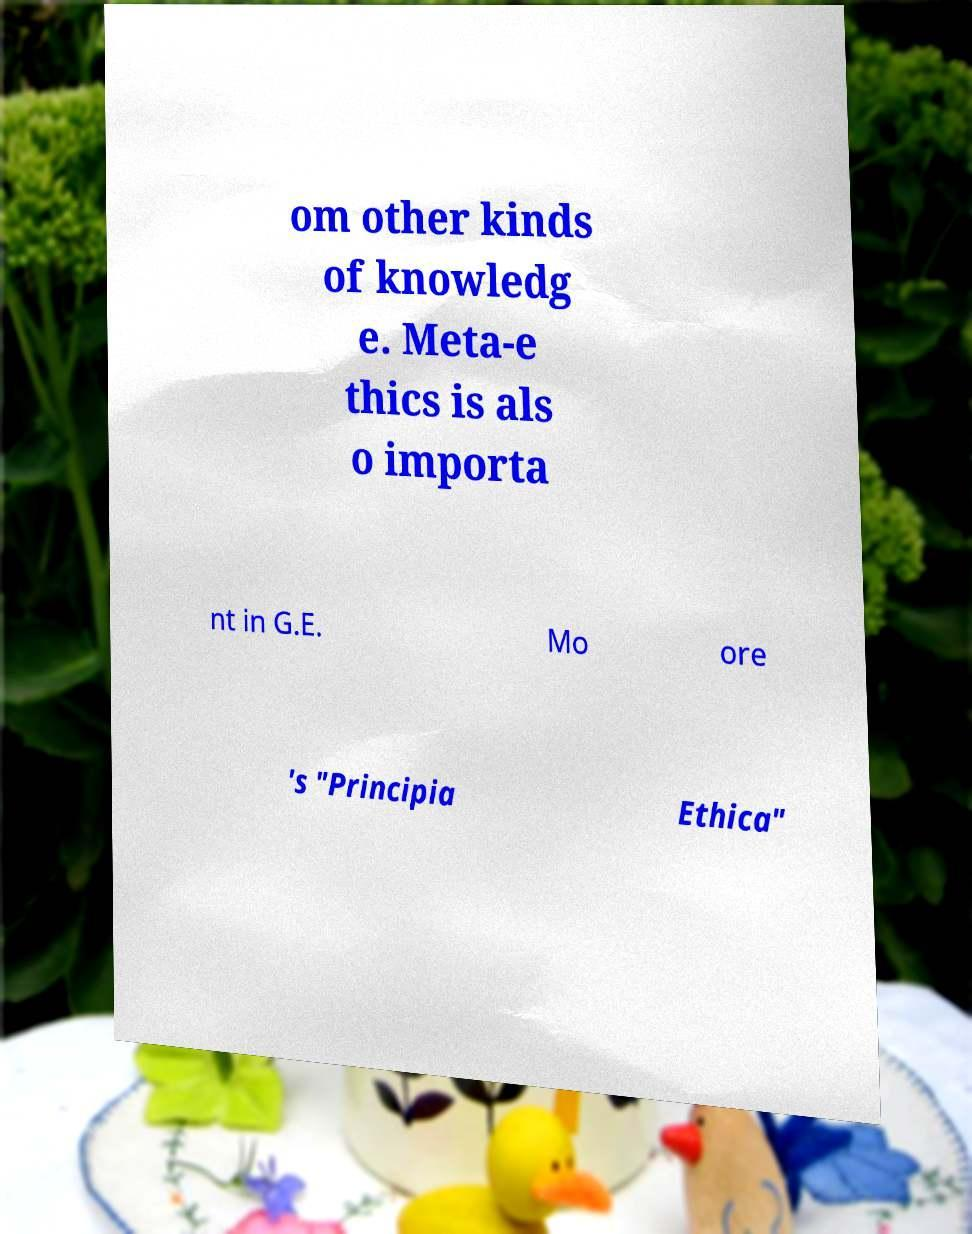Please read and relay the text visible in this image. What does it say? om other kinds of knowledg e. Meta-e thics is als o importa nt in G.E. Mo ore 's "Principia Ethica" 